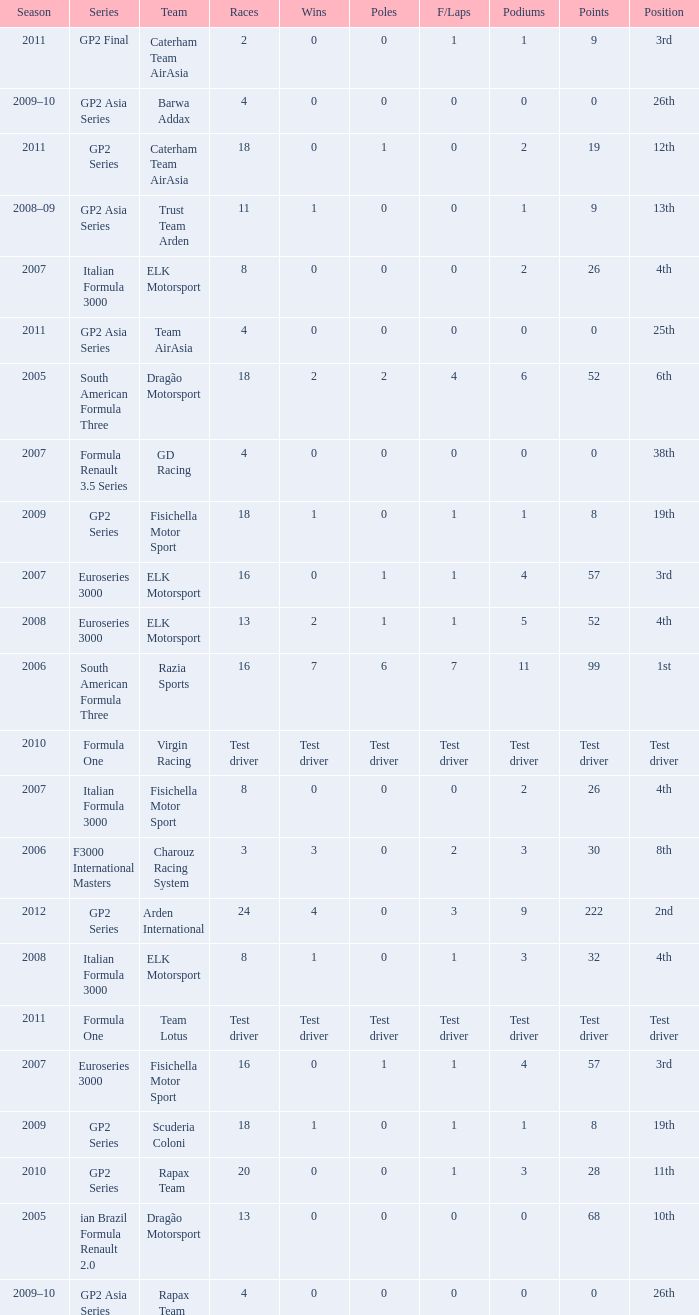In which season did he have 0 Poles and 19th position in the GP2 Series? 2009, 2009. 